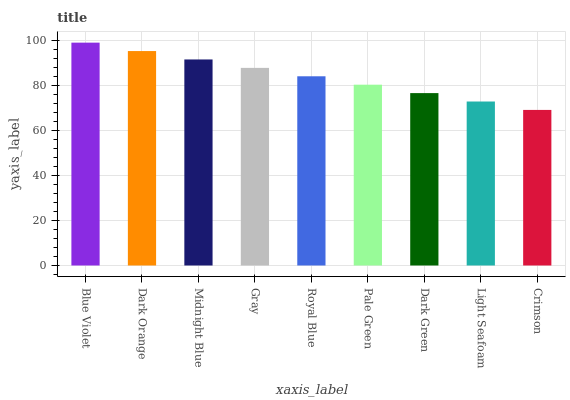Is Crimson the minimum?
Answer yes or no. Yes. Is Blue Violet the maximum?
Answer yes or no. Yes. Is Dark Orange the minimum?
Answer yes or no. No. Is Dark Orange the maximum?
Answer yes or no. No. Is Blue Violet greater than Dark Orange?
Answer yes or no. Yes. Is Dark Orange less than Blue Violet?
Answer yes or no. Yes. Is Dark Orange greater than Blue Violet?
Answer yes or no. No. Is Blue Violet less than Dark Orange?
Answer yes or no. No. Is Royal Blue the high median?
Answer yes or no. Yes. Is Royal Blue the low median?
Answer yes or no. Yes. Is Midnight Blue the high median?
Answer yes or no. No. Is Gray the low median?
Answer yes or no. No. 